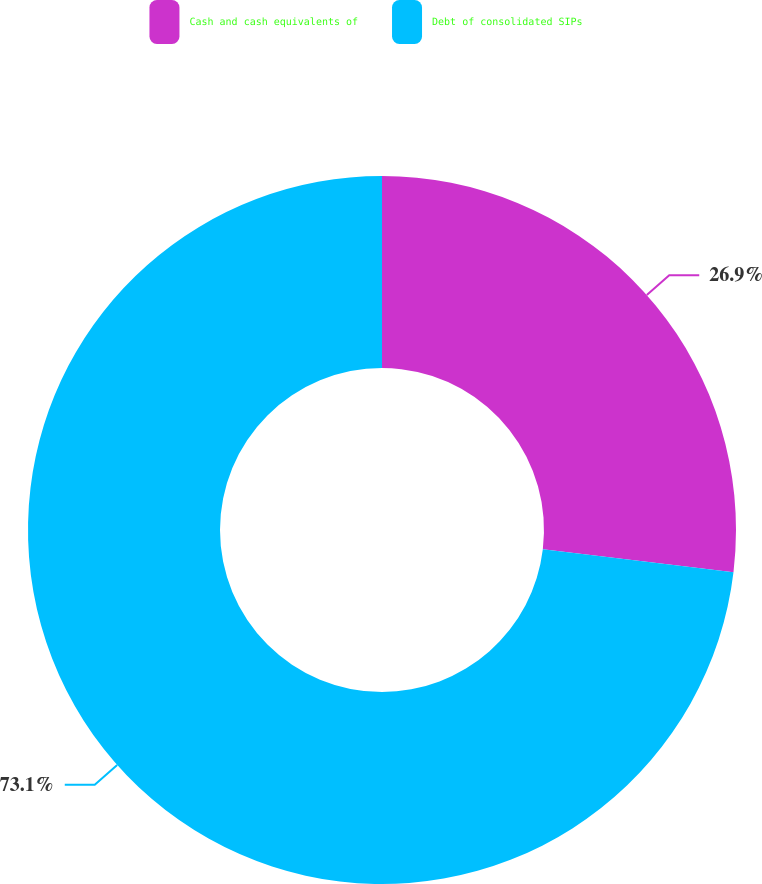Convert chart. <chart><loc_0><loc_0><loc_500><loc_500><pie_chart><fcel>Cash and cash equivalents of<fcel>Debt of consolidated SIPs<nl><fcel>26.9%<fcel>73.1%<nl></chart> 